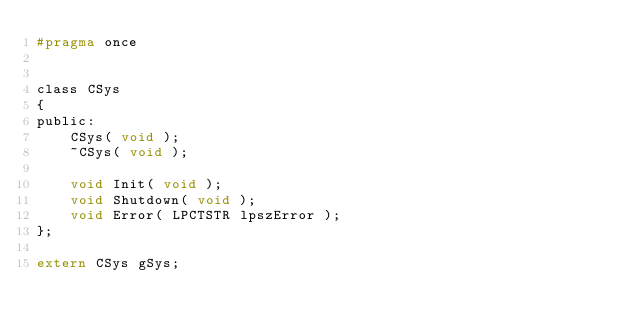<code> <loc_0><loc_0><loc_500><loc_500><_C_>#pragma once


class CSys
{
public:
	CSys( void );
	~CSys( void );

	void Init( void );
	void Shutdown( void );
	void Error( LPCTSTR lpszError );
};

extern CSys gSys;</code> 